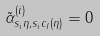Convert formula to latex. <formula><loc_0><loc_0><loc_500><loc_500>\tilde { \alpha } ^ { ( i ) } _ { s _ { i } \eta , s _ { i } c _ { I } ( \eta ) } = 0</formula> 